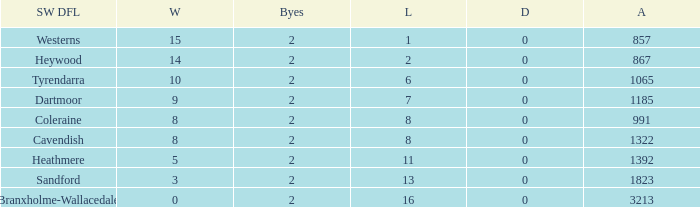Which draws have an average of 14 wins? 0.0. 